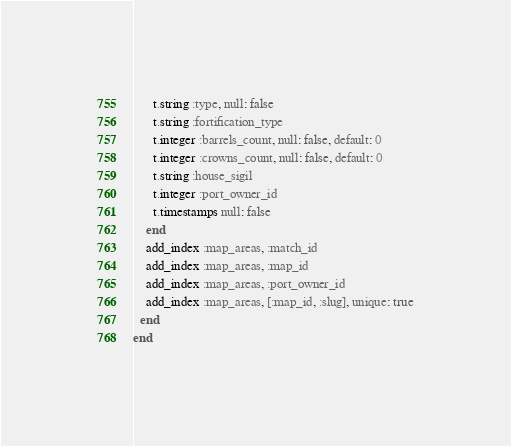<code> <loc_0><loc_0><loc_500><loc_500><_Ruby_>      t.string :type, null: false
      t.string :fortification_type
      t.integer :barrels_count, null: false, default: 0
      t.integer :crowns_count, null: false, default: 0
      t.string :house_sigil
      t.integer :port_owner_id
      t.timestamps null: false
    end
    add_index :map_areas, :match_id
    add_index :map_areas, :map_id
    add_index :map_areas, :port_owner_id
    add_index :map_areas, [:map_id, :slug], unique: true
  end
end
</code> 